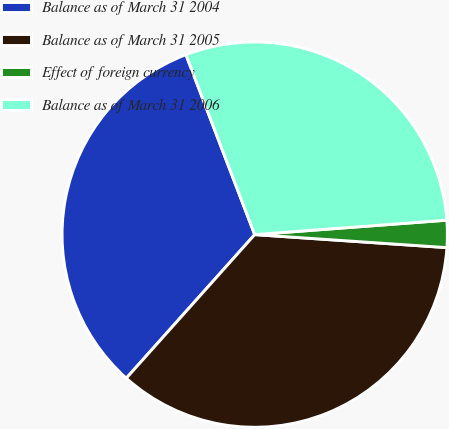<chart> <loc_0><loc_0><loc_500><loc_500><pie_chart><fcel>Balance as of March 31 2004<fcel>Balance as of March 31 2005<fcel>Effect of foreign currency<fcel>Balance as of March 31 2006<nl><fcel>32.58%<fcel>35.54%<fcel>2.27%<fcel>29.62%<nl></chart> 